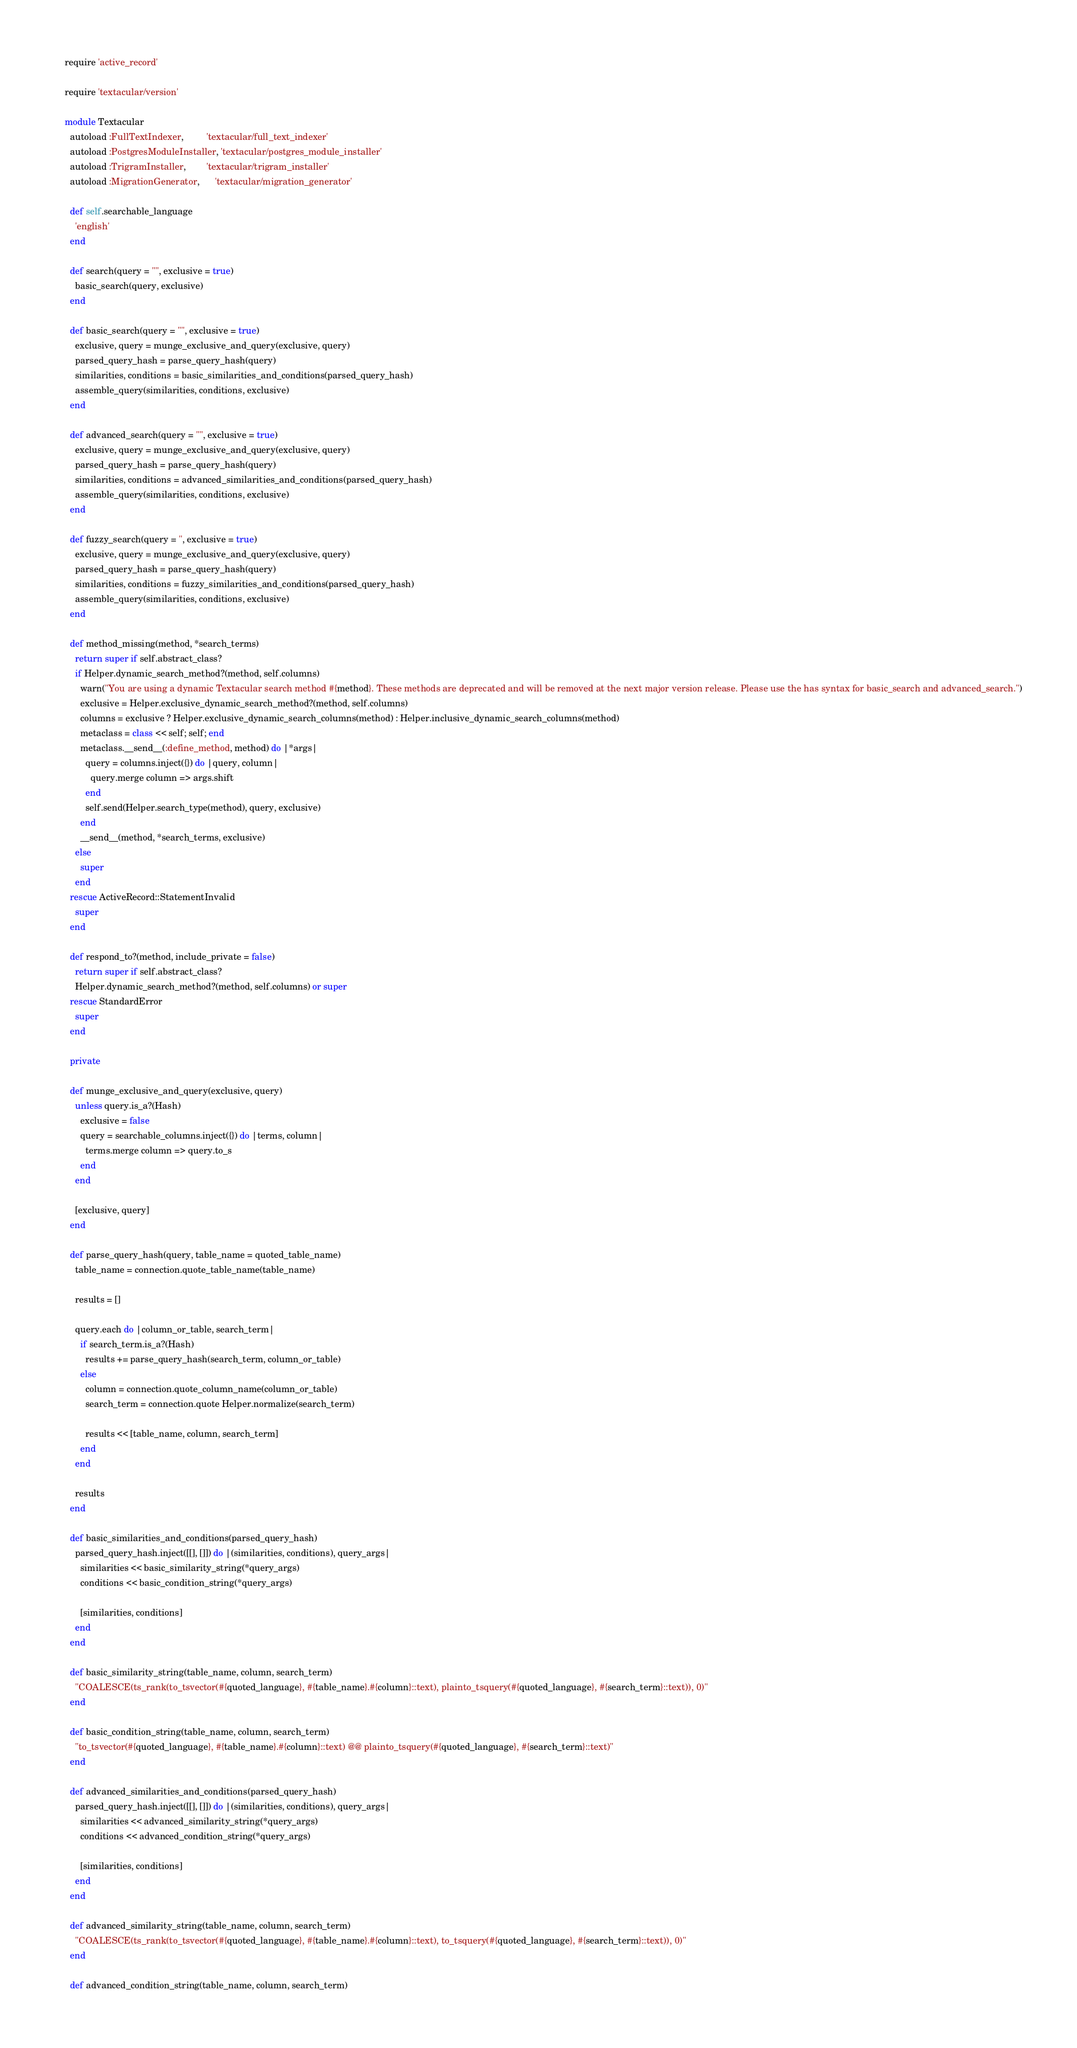<code> <loc_0><loc_0><loc_500><loc_500><_Ruby_>require 'active_record'

require 'textacular/version'

module Textacular
  autoload :FullTextIndexer,         'textacular/full_text_indexer'
  autoload :PostgresModuleInstaller, 'textacular/postgres_module_installer'
  autoload :TrigramInstaller,        'textacular/trigram_installer'
  autoload :MigrationGenerator,      'textacular/migration_generator'

  def self.searchable_language
    'english'
  end

  def search(query = "", exclusive = true)
    basic_search(query, exclusive)
  end

  def basic_search(query = "", exclusive = true)
    exclusive, query = munge_exclusive_and_query(exclusive, query)
    parsed_query_hash = parse_query_hash(query)
    similarities, conditions = basic_similarities_and_conditions(parsed_query_hash)
    assemble_query(similarities, conditions, exclusive)
  end

  def advanced_search(query = "", exclusive = true)
    exclusive, query = munge_exclusive_and_query(exclusive, query)
    parsed_query_hash = parse_query_hash(query)
    similarities, conditions = advanced_similarities_and_conditions(parsed_query_hash)
    assemble_query(similarities, conditions, exclusive)
  end

  def fuzzy_search(query = '', exclusive = true)
    exclusive, query = munge_exclusive_and_query(exclusive, query)
    parsed_query_hash = parse_query_hash(query)
    similarities, conditions = fuzzy_similarities_and_conditions(parsed_query_hash)
    assemble_query(similarities, conditions, exclusive)
  end

  def method_missing(method, *search_terms)
    return super if self.abstract_class?
    if Helper.dynamic_search_method?(method, self.columns)
      warn("You are using a dynamic Textacular search method #{method}. These methods are deprecated and will be removed at the next major version release. Please use the has syntax for basic_search and advanced_search.")
      exclusive = Helper.exclusive_dynamic_search_method?(method, self.columns)
      columns = exclusive ? Helper.exclusive_dynamic_search_columns(method) : Helper.inclusive_dynamic_search_columns(method)
      metaclass = class << self; self; end
      metaclass.__send__(:define_method, method) do |*args|
        query = columns.inject({}) do |query, column|
          query.merge column => args.shift
        end
        self.send(Helper.search_type(method), query, exclusive)
      end
      __send__(method, *search_terms, exclusive)
    else
      super
    end
  rescue ActiveRecord::StatementInvalid
    super
  end

  def respond_to?(method, include_private = false)
    return super if self.abstract_class?
    Helper.dynamic_search_method?(method, self.columns) or super
  rescue StandardError
    super
  end

  private

  def munge_exclusive_and_query(exclusive, query)
    unless query.is_a?(Hash)
      exclusive = false
      query = searchable_columns.inject({}) do |terms, column|
        terms.merge column => query.to_s
      end
    end

    [exclusive, query]
  end

  def parse_query_hash(query, table_name = quoted_table_name)
    table_name = connection.quote_table_name(table_name)

    results = []

    query.each do |column_or_table, search_term|
      if search_term.is_a?(Hash)
        results += parse_query_hash(search_term, column_or_table)
      else
        column = connection.quote_column_name(column_or_table)
        search_term = connection.quote Helper.normalize(search_term)

        results << [table_name, column, search_term]
      end
    end

    results
  end

  def basic_similarities_and_conditions(parsed_query_hash)
    parsed_query_hash.inject([[], []]) do |(similarities, conditions), query_args|
      similarities << basic_similarity_string(*query_args)
      conditions << basic_condition_string(*query_args)

      [similarities, conditions]
    end
  end

  def basic_similarity_string(table_name, column, search_term)
    "COALESCE(ts_rank(to_tsvector(#{quoted_language}, #{table_name}.#{column}::text), plainto_tsquery(#{quoted_language}, #{search_term}::text)), 0)"
  end

  def basic_condition_string(table_name, column, search_term)
    "to_tsvector(#{quoted_language}, #{table_name}.#{column}::text) @@ plainto_tsquery(#{quoted_language}, #{search_term}::text)"
  end

  def advanced_similarities_and_conditions(parsed_query_hash)
    parsed_query_hash.inject([[], []]) do |(similarities, conditions), query_args|
      similarities << advanced_similarity_string(*query_args)
      conditions << advanced_condition_string(*query_args)

      [similarities, conditions]
    end
  end

  def advanced_similarity_string(table_name, column, search_term)
    "COALESCE(ts_rank(to_tsvector(#{quoted_language}, #{table_name}.#{column}::text), to_tsquery(#{quoted_language}, #{search_term}::text)), 0)"
  end

  def advanced_condition_string(table_name, column, search_term)</code> 